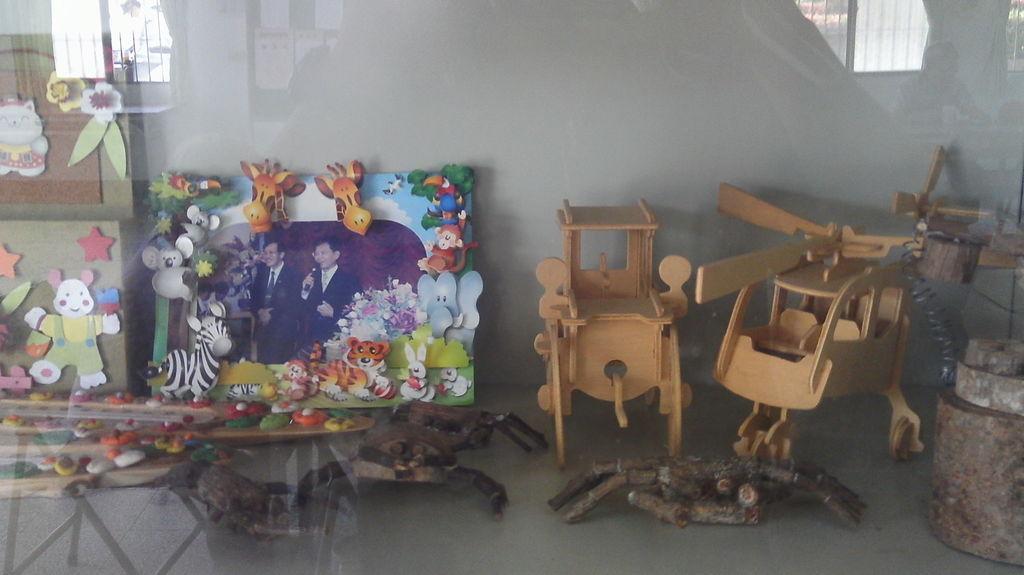How would you summarize this image in a sentence or two? In this image, we can see two wooden objects, there are two paintings and we can see the floor. 